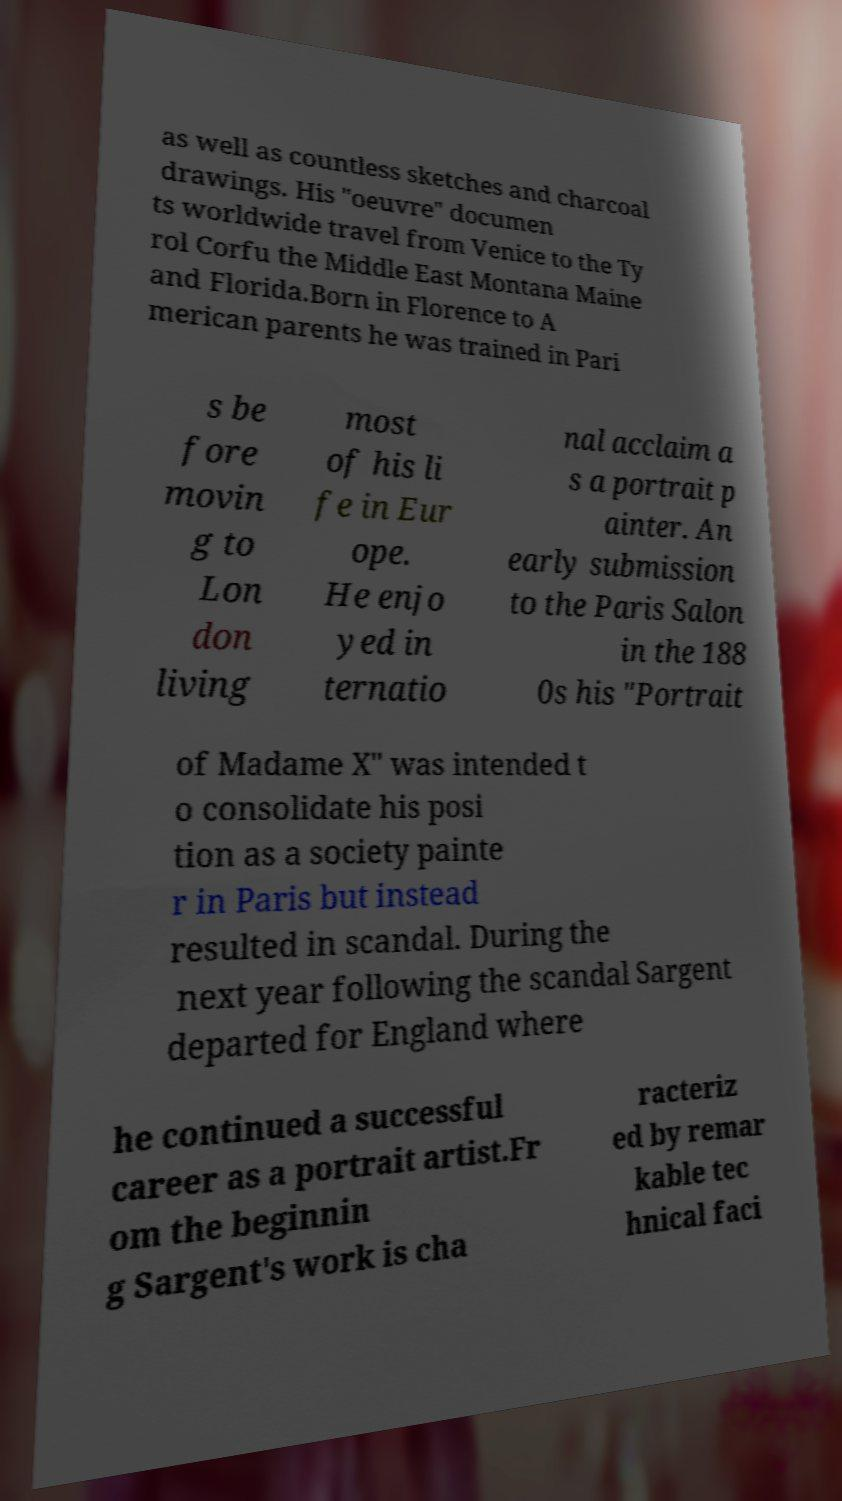Could you extract and type out the text from this image? as well as countless sketches and charcoal drawings. His "oeuvre" documen ts worldwide travel from Venice to the Ty rol Corfu the Middle East Montana Maine and Florida.Born in Florence to A merican parents he was trained in Pari s be fore movin g to Lon don living most of his li fe in Eur ope. He enjo yed in ternatio nal acclaim a s a portrait p ainter. An early submission to the Paris Salon in the 188 0s his "Portrait of Madame X" was intended t o consolidate his posi tion as a society painte r in Paris but instead resulted in scandal. During the next year following the scandal Sargent departed for England where he continued a successful career as a portrait artist.Fr om the beginnin g Sargent's work is cha racteriz ed by remar kable tec hnical faci 